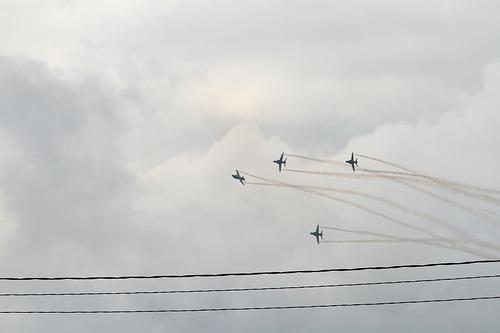How many planes are shown?
Give a very brief answer. 4. 